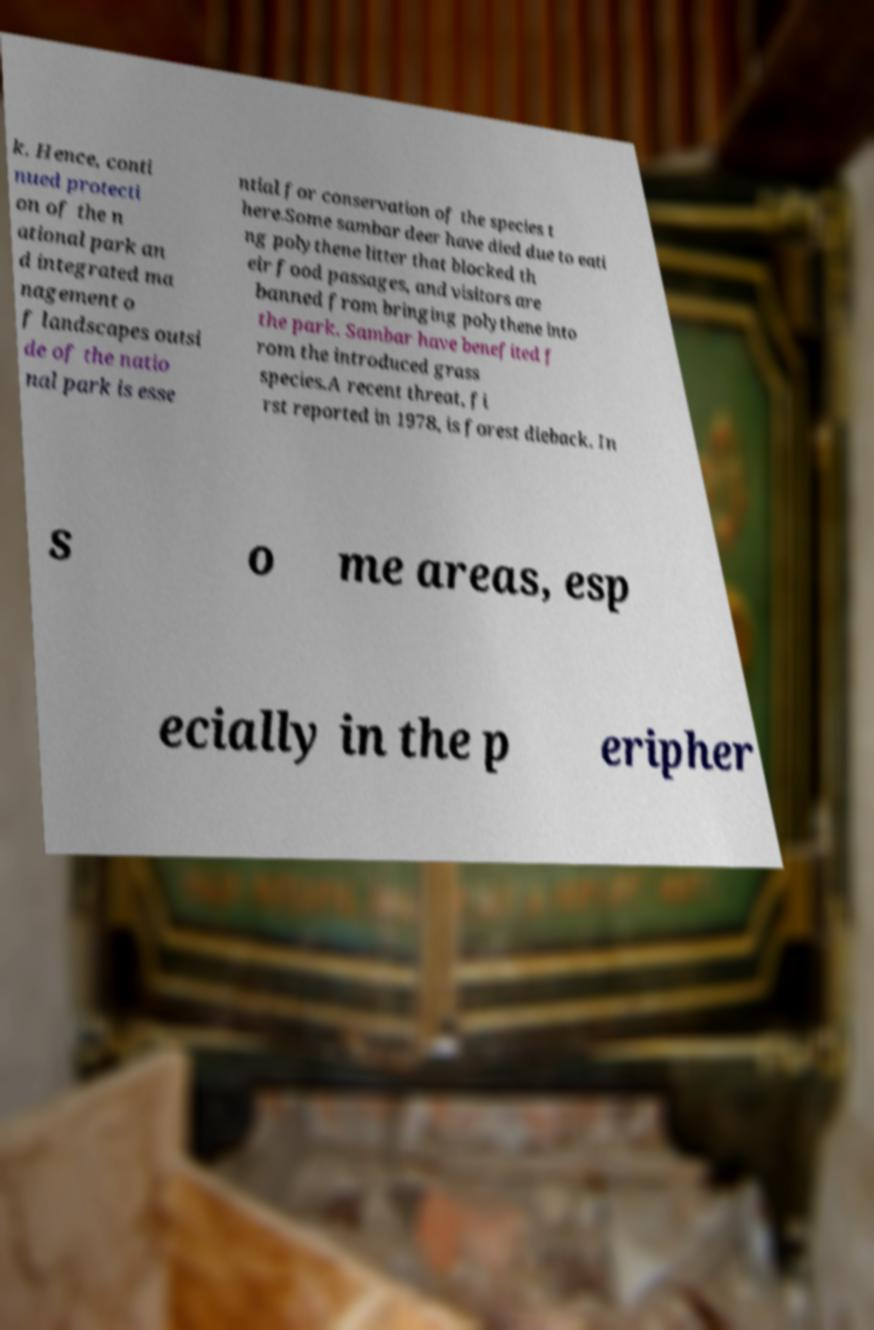Can you read and provide the text displayed in the image?This photo seems to have some interesting text. Can you extract and type it out for me? k. Hence, conti nued protecti on of the n ational park an d integrated ma nagement o f landscapes outsi de of the natio nal park is esse ntial for conservation of the species t here.Some sambar deer have died due to eati ng polythene litter that blocked th eir food passages, and visitors are banned from bringing polythene into the park. Sambar have benefited f rom the introduced grass species.A recent threat, fi rst reported in 1978, is forest dieback. In s o me areas, esp ecially in the p eripher 